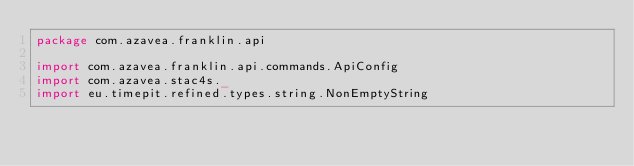Convert code to text. <code><loc_0><loc_0><loc_500><loc_500><_Scala_>package com.azavea.franklin.api

import com.azavea.franklin.api.commands.ApiConfig
import com.azavea.stac4s._
import eu.timepit.refined.types.string.NonEmptyString
</code> 